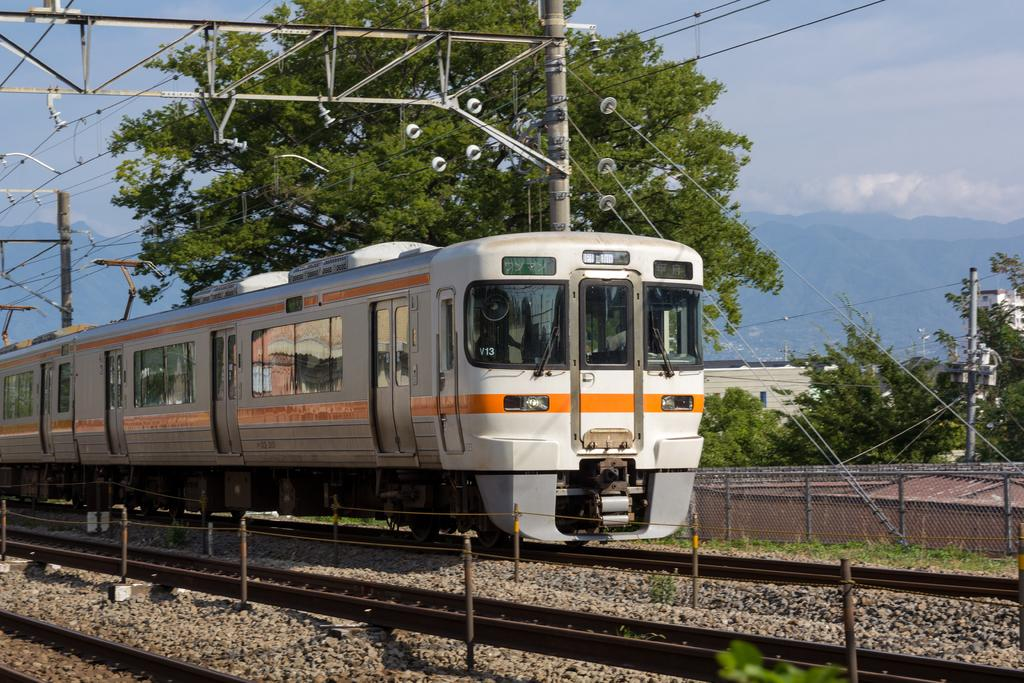What is the main subject of the image? The main subject of the image is a train. Where is the train located in the image? The train is on a railway track. What can be seen in the background of the image? In the background of the image, there is sky, trees, poles with wires, grass, and other objects. How much honey is being transported by the train in the image? There is no indication of honey being transported by the train in the image. Is there a crook visible in the image? There is no crook present in the image. 